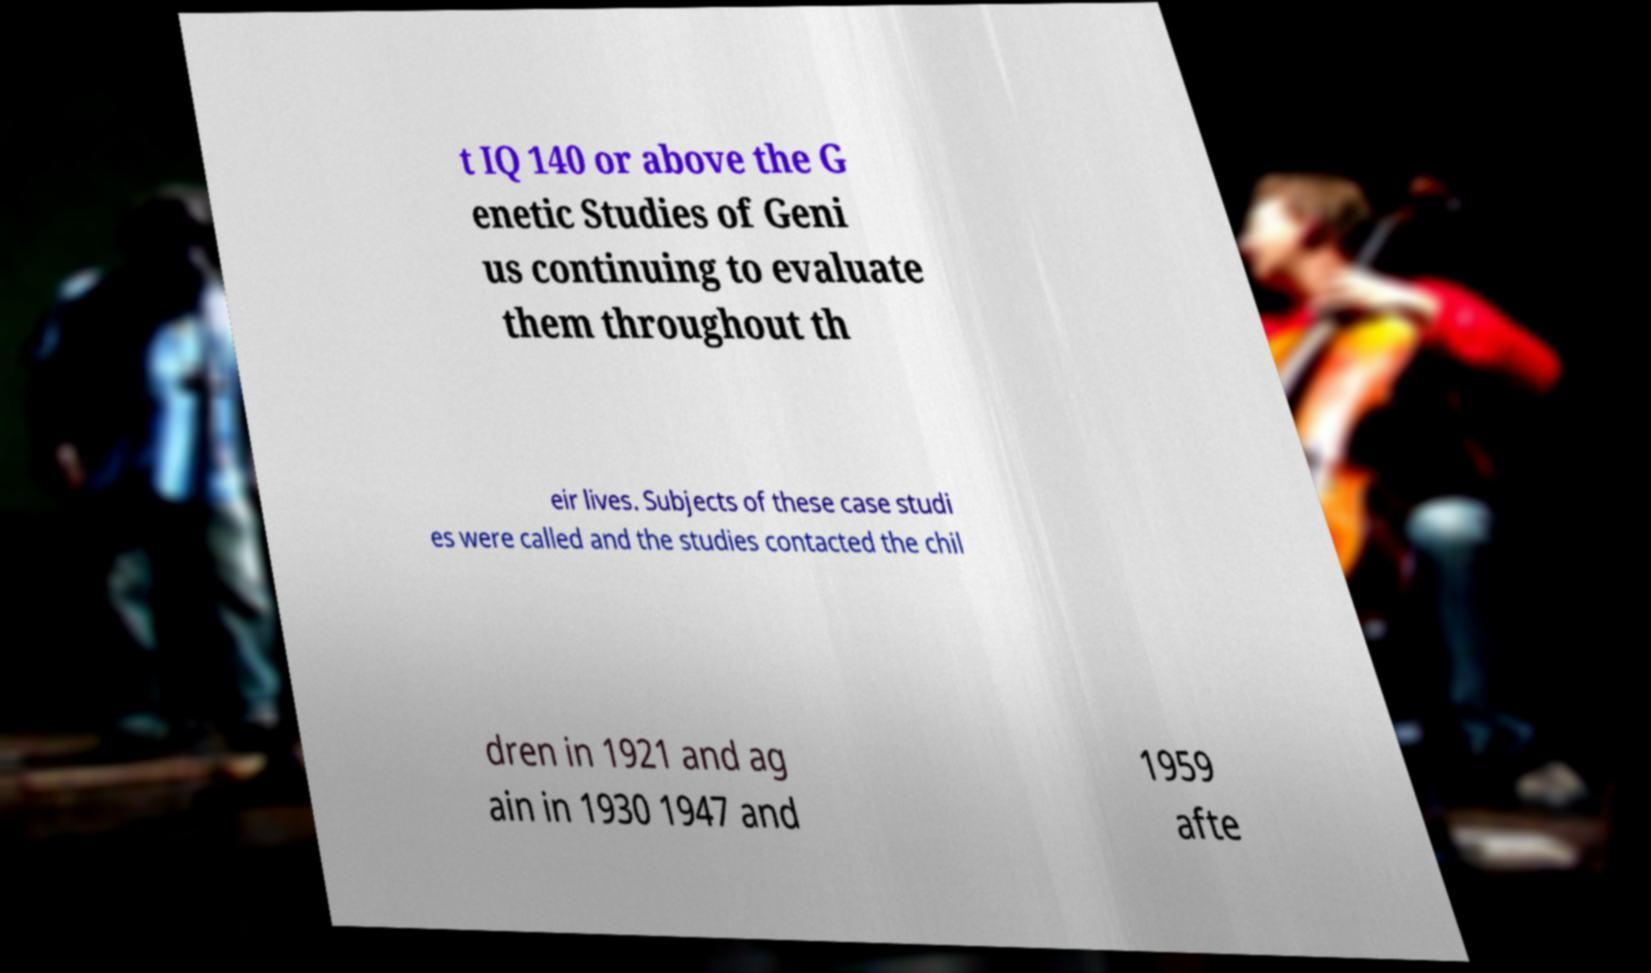Can you read and provide the text displayed in the image?This photo seems to have some interesting text. Can you extract and type it out for me? t IQ 140 or above the G enetic Studies of Geni us continuing to evaluate them throughout th eir lives. Subjects of these case studi es were called and the studies contacted the chil dren in 1921 and ag ain in 1930 1947 and 1959 afte 